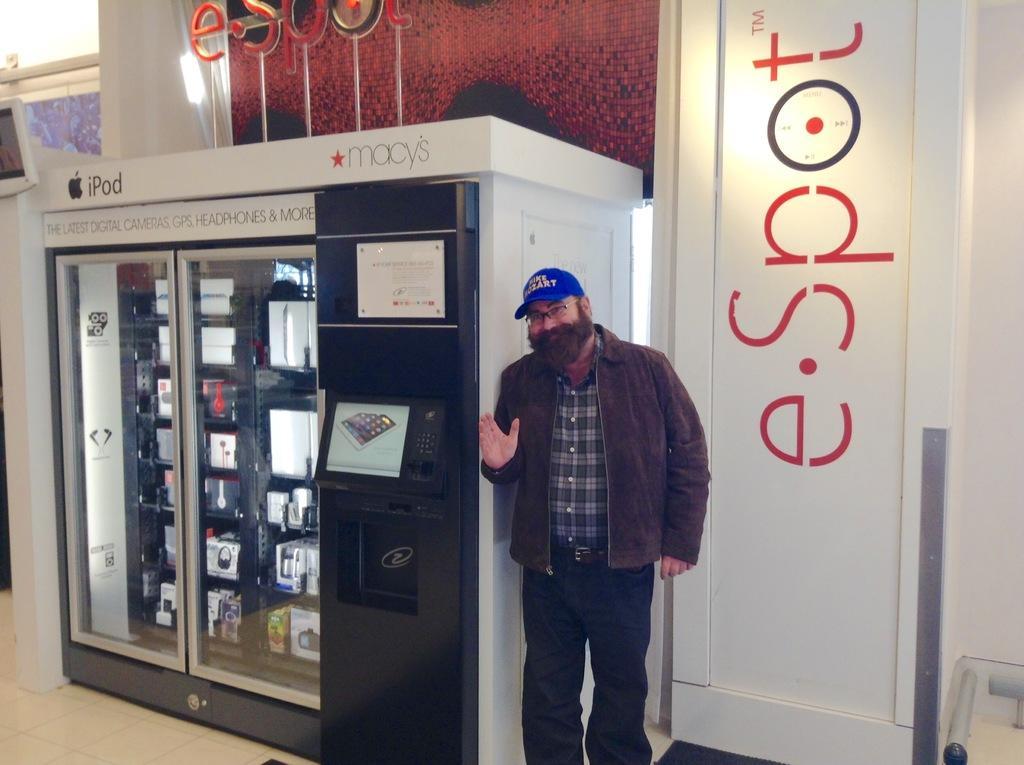Describe this image in one or two sentences. In the foreground I can see a person is standing on the floor beside a cupboard. In the background I can see a wall, curtain and a door. This image is taken may be in a hall. 